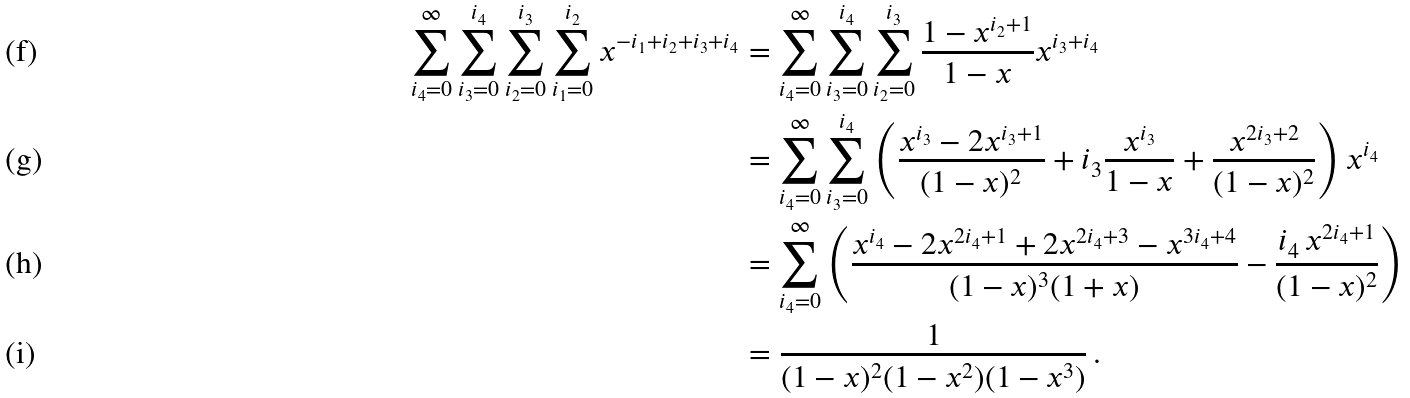Convert formula to latex. <formula><loc_0><loc_0><loc_500><loc_500>\sum _ { i _ { 4 } = 0 } ^ { \infty } \sum _ { i _ { 3 } = 0 } ^ { i _ { 4 } } \sum _ { i _ { 2 } = 0 } ^ { i _ { 3 } } \sum _ { i _ { 1 } = 0 } ^ { i _ { 2 } } x ^ { - i _ { 1 } + i _ { 2 } + i _ { 3 } + i _ { 4 } } & = \sum _ { i _ { 4 } = 0 } ^ { \infty } \sum _ { i _ { 3 } = 0 } ^ { i _ { 4 } } \sum _ { i _ { 2 } = 0 } ^ { i _ { 3 } } \frac { 1 - x ^ { i _ { 2 } + 1 } } { 1 - x } x ^ { i _ { 3 } + i _ { 4 } } \\ & = \sum _ { i _ { 4 } = 0 } ^ { \infty } \sum _ { i _ { 3 } = 0 } ^ { i _ { 4 } } \left ( \frac { x ^ { i _ { 3 } } - 2 x ^ { i _ { 3 } + 1 } } { ( 1 - x ) ^ { 2 } } + i _ { 3 } \frac { x ^ { i _ { 3 } } } { 1 - x } + \frac { x ^ { 2 i _ { 3 } + 2 } } { ( 1 - x ) ^ { 2 } } \right ) x ^ { i _ { 4 } } \\ & = \sum _ { i _ { 4 } = 0 } ^ { \infty } \left ( \frac { x ^ { i _ { 4 } } - 2 x ^ { 2 i _ { 4 } + 1 } + 2 x ^ { 2 i _ { 4 } + 3 } - x ^ { 3 i _ { 4 } + 4 } } { ( 1 - x ) ^ { 3 } ( 1 + x ) } - \frac { i _ { 4 } \, x ^ { 2 i _ { 4 } + 1 } } { ( 1 - x ) ^ { 2 } } \right ) \\ & = \frac { 1 } { ( 1 - x ) ^ { 2 } ( 1 - x ^ { 2 } ) ( 1 - x ^ { 3 } ) } \, .</formula> 